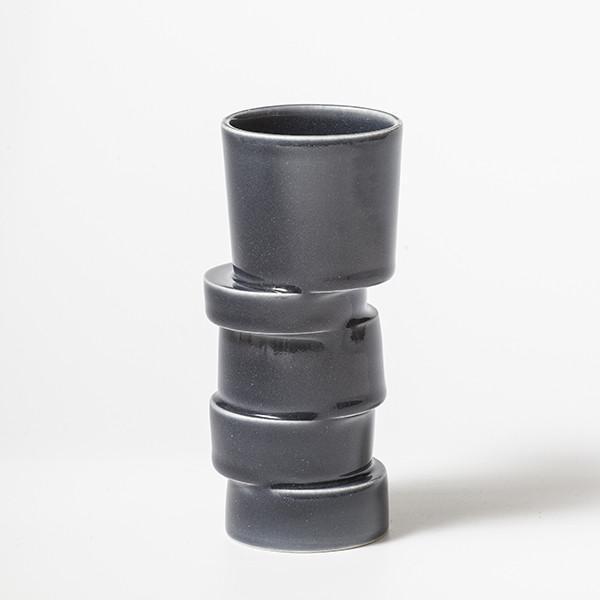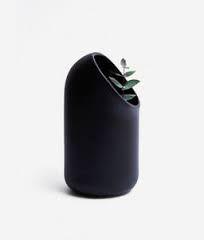The first image is the image on the left, the second image is the image on the right. Assess this claim about the two images: "At least one of the vases contains a plant with leaves.". Correct or not? Answer yes or no. Yes. The first image is the image on the left, the second image is the image on the right. Analyze the images presented: Is the assertion "There are 4 vases standing upright." valid? Answer yes or no. No. 